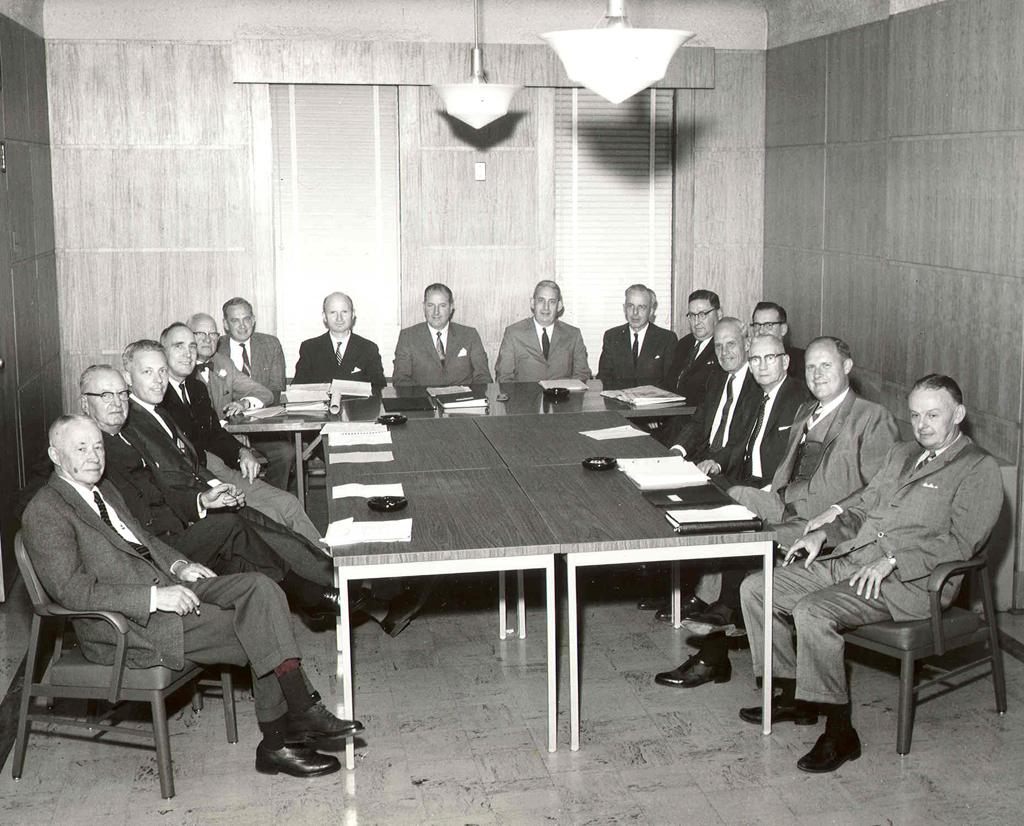How many people are in the image? There is a group of persons in the image. What are the persons doing in the image? The persons are sitting on chairs around a table. What items can be seen on the table? There are papers and a chart on the table. What can be seen in the background of the image? There is a wall, a door, and a light in the background. What word is written on the light bulb in the image? There is no light bulb present in the image, and therefore no word can be read on it. 